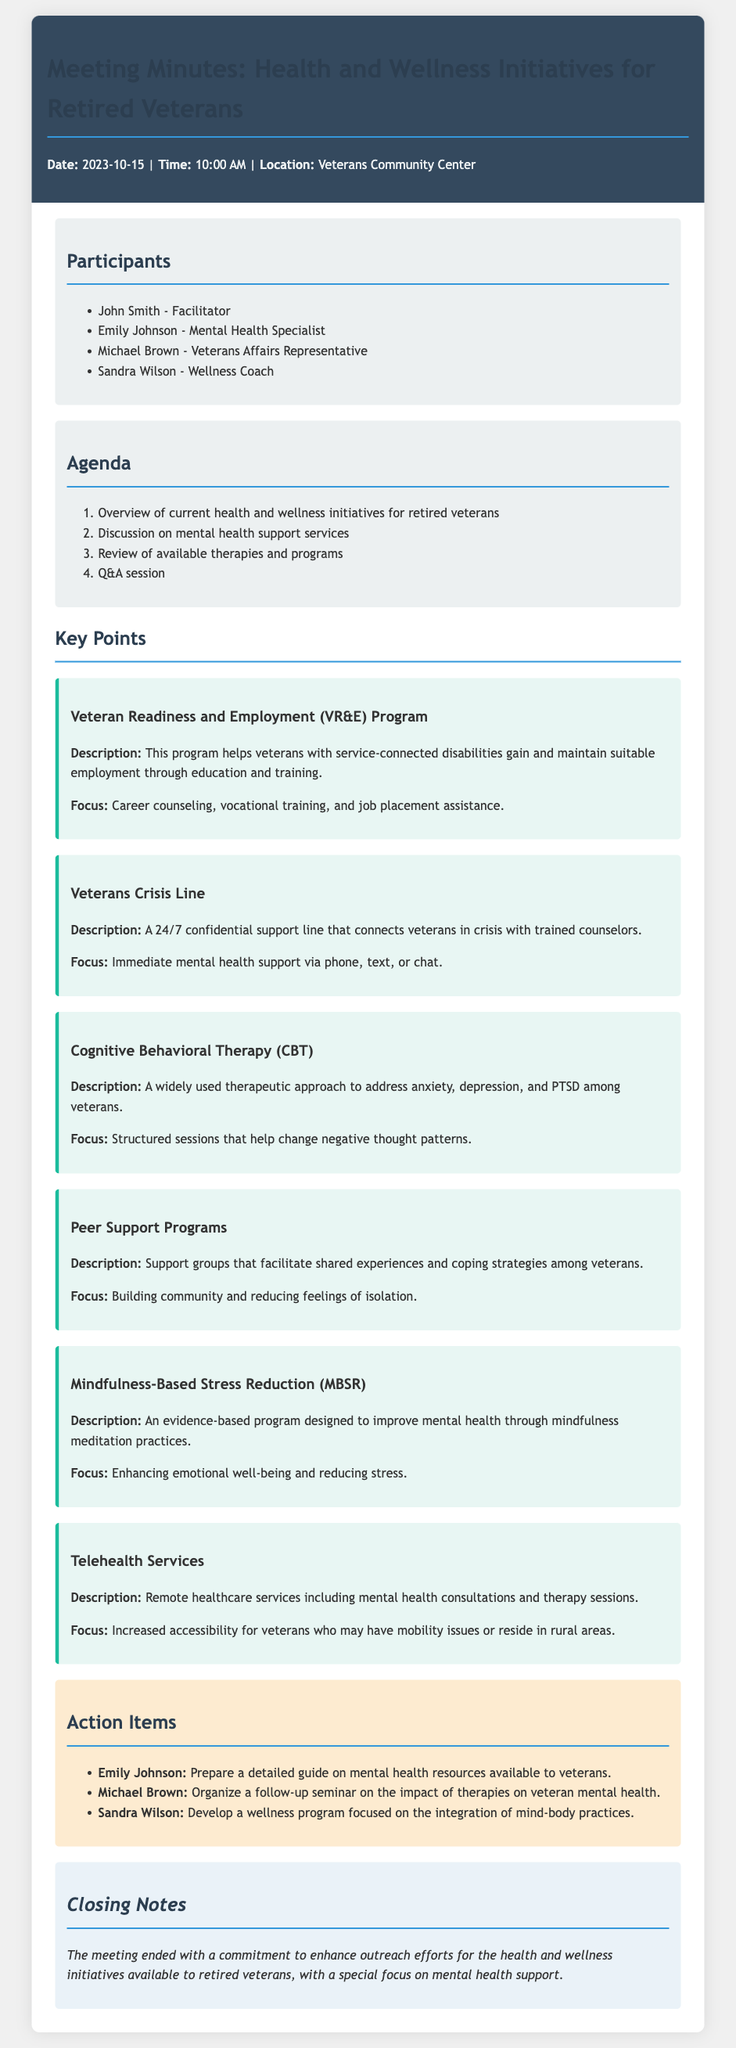What is the date of the meeting? The date of the meeting is stated in the document as 2023-10-15.
Answer: 2023-10-15 Who is the facilitator of the meeting? The facilitator is listed among the participants.
Answer: John Smith What therapy is focused on changing negative thought patterns? The document specifies Cognitive Behavioral Therapy as the therapeutic approach addressing this issue.
Answer: Cognitive Behavioral Therapy How many main initiatives are listed in the key points? The initiatives are detailed in the key points section, totaling six.
Answer: Six What is the focus of the Veterans Crisis Line? The document outlines the main focus as providing immediate mental health support.
Answer: Immediate mental health support Which participant is responsible for preparing a guide on mental health resources? The action items specify Emily Johnson as responsible for this task.
Answer: Emily Johnson What type of service is enhanced by Telehealth Services? Telehealth Services enhance accessibility of remote healthcare services, specifically mentioned as including mental health consultations.
Answer: Remote healthcare services What is the primary goal of the Peer Support Programs? The programs aim to build community among veterans and reduce feelings of isolation.
Answer: Building community and reducing feelings of isolation 